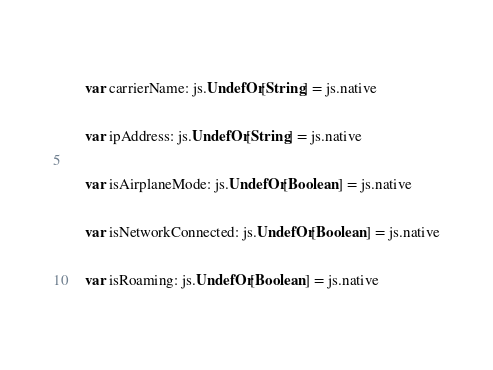Convert code to text. <code><loc_0><loc_0><loc_500><loc_500><_Scala_>    
    var carrierName: js.UndefOr[String] = js.native
    
    var ipAddress: js.UndefOr[String] = js.native
    
    var isAirplaneMode: js.UndefOr[Boolean] = js.native
    
    var isNetworkConnected: js.UndefOr[Boolean] = js.native
    
    var isRoaming: js.UndefOr[Boolean] = js.native
    </code> 